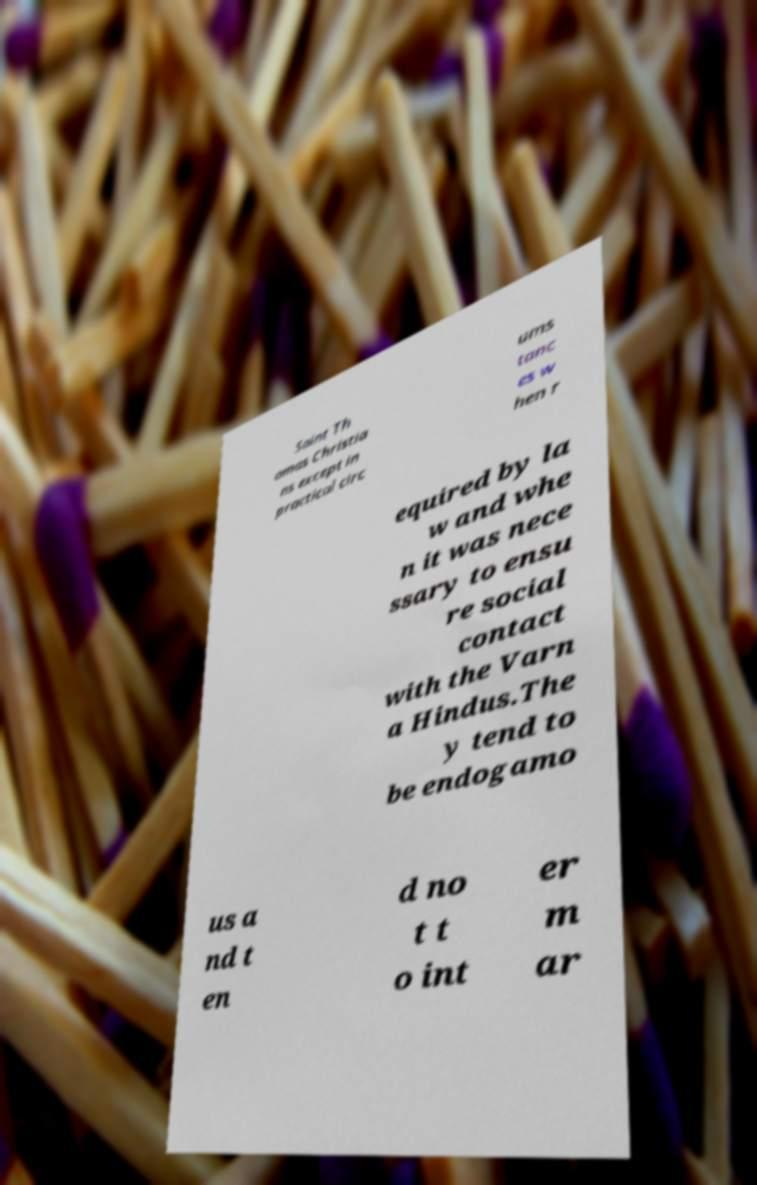Please identify and transcribe the text found in this image. Saint Th omas Christia ns except in practical circ ums tanc es w hen r equired by la w and whe n it was nece ssary to ensu re social contact with the Varn a Hindus.The y tend to be endogamo us a nd t en d no t t o int er m ar 